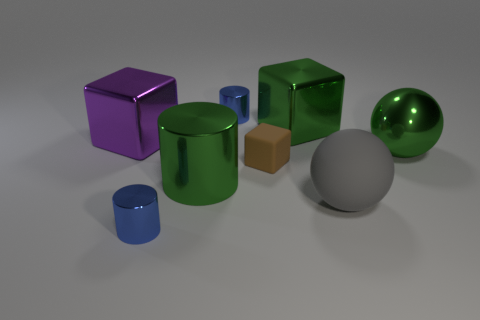What color is the small object that is in front of the big purple thing and behind the rubber ball?
Your response must be concise. Brown. What number of other objects are the same material as the green block?
Offer a terse response. 5. Are there fewer gray balls than small brown metal balls?
Your answer should be compact. No. Does the purple object have the same material as the blue object behind the big metal ball?
Provide a short and direct response. Yes. There is a matte object that is on the right side of the tiny block; what shape is it?
Your answer should be compact. Sphere. Is there anything else of the same color as the matte ball?
Offer a very short reply. No. Are there fewer large metallic blocks on the right side of the large purple metallic block than gray objects?
Offer a very short reply. No. What number of spheres have the same size as the gray rubber object?
Offer a terse response. 1. What is the shape of the small object on the left side of the blue metallic cylinder that is behind the tiny blue object in front of the gray object?
Your answer should be very brief. Cylinder. What is the color of the tiny shiny cylinder that is behind the large metal sphere?
Ensure brevity in your answer.  Blue. 